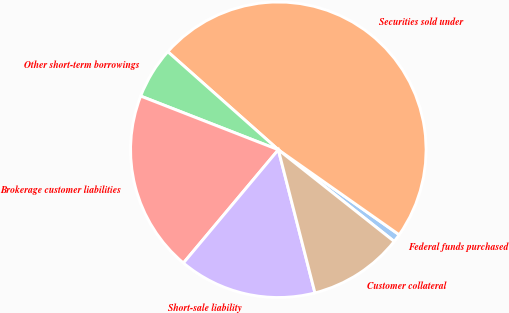<chart> <loc_0><loc_0><loc_500><loc_500><pie_chart><fcel>Federal funds purchased<fcel>Securities sold under<fcel>Other short-term borrowings<fcel>Brokerage customer liabilities<fcel>Short-sale liability<fcel>Customer collateral<nl><fcel>0.9%<fcel>48.21%<fcel>5.63%<fcel>19.82%<fcel>15.09%<fcel>10.36%<nl></chart> 